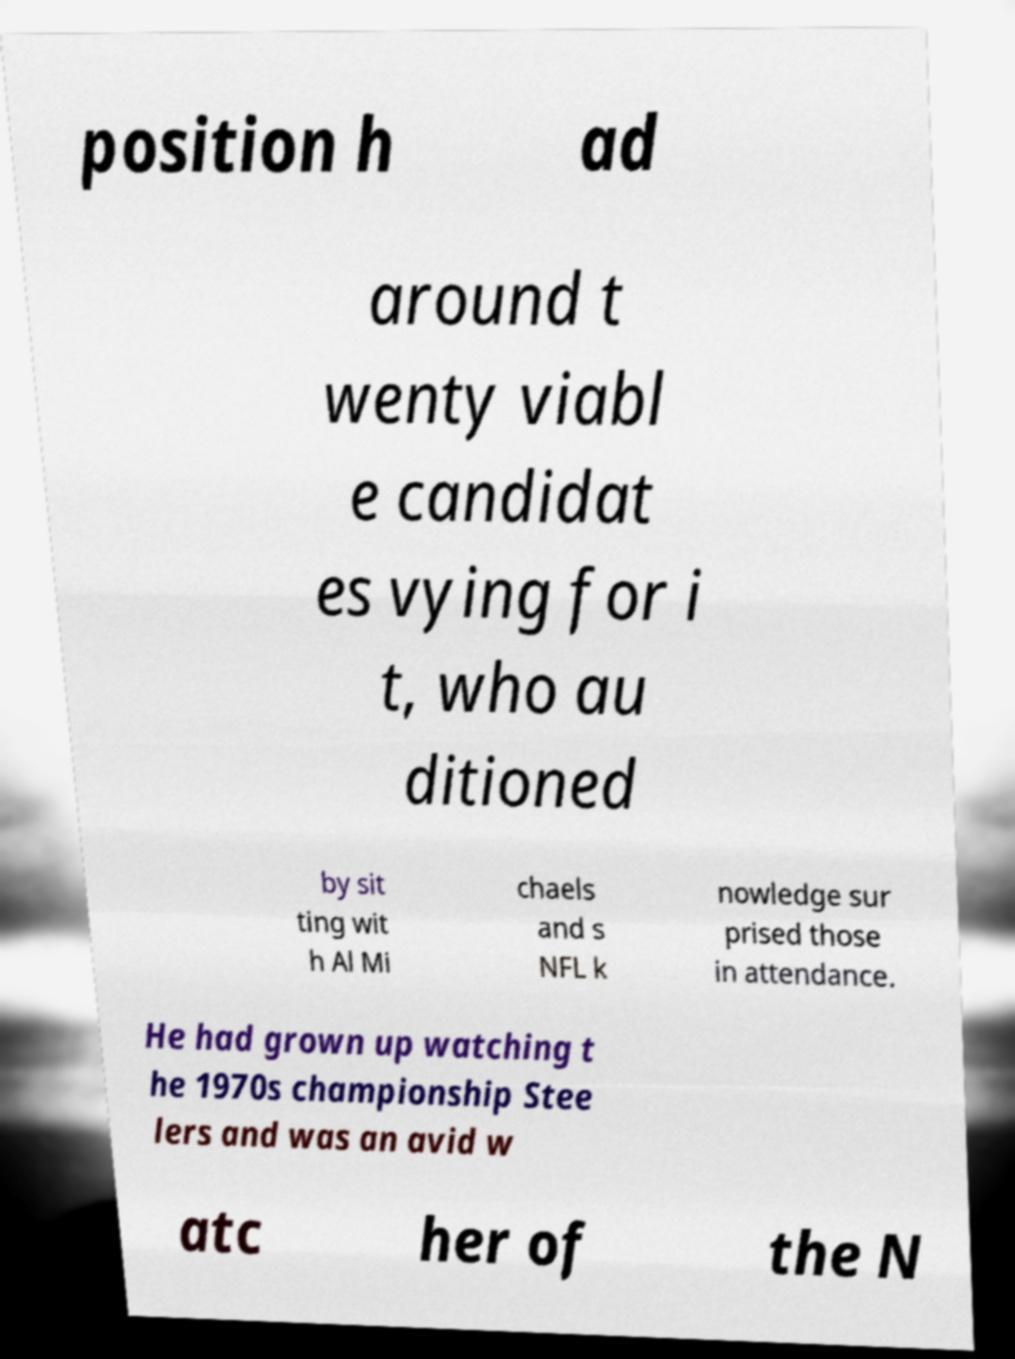Could you assist in decoding the text presented in this image and type it out clearly? position h ad around t wenty viabl e candidat es vying for i t, who au ditioned by sit ting wit h Al Mi chaels and s NFL k nowledge sur prised those in attendance. He had grown up watching t he 1970s championship Stee lers and was an avid w atc her of the N 